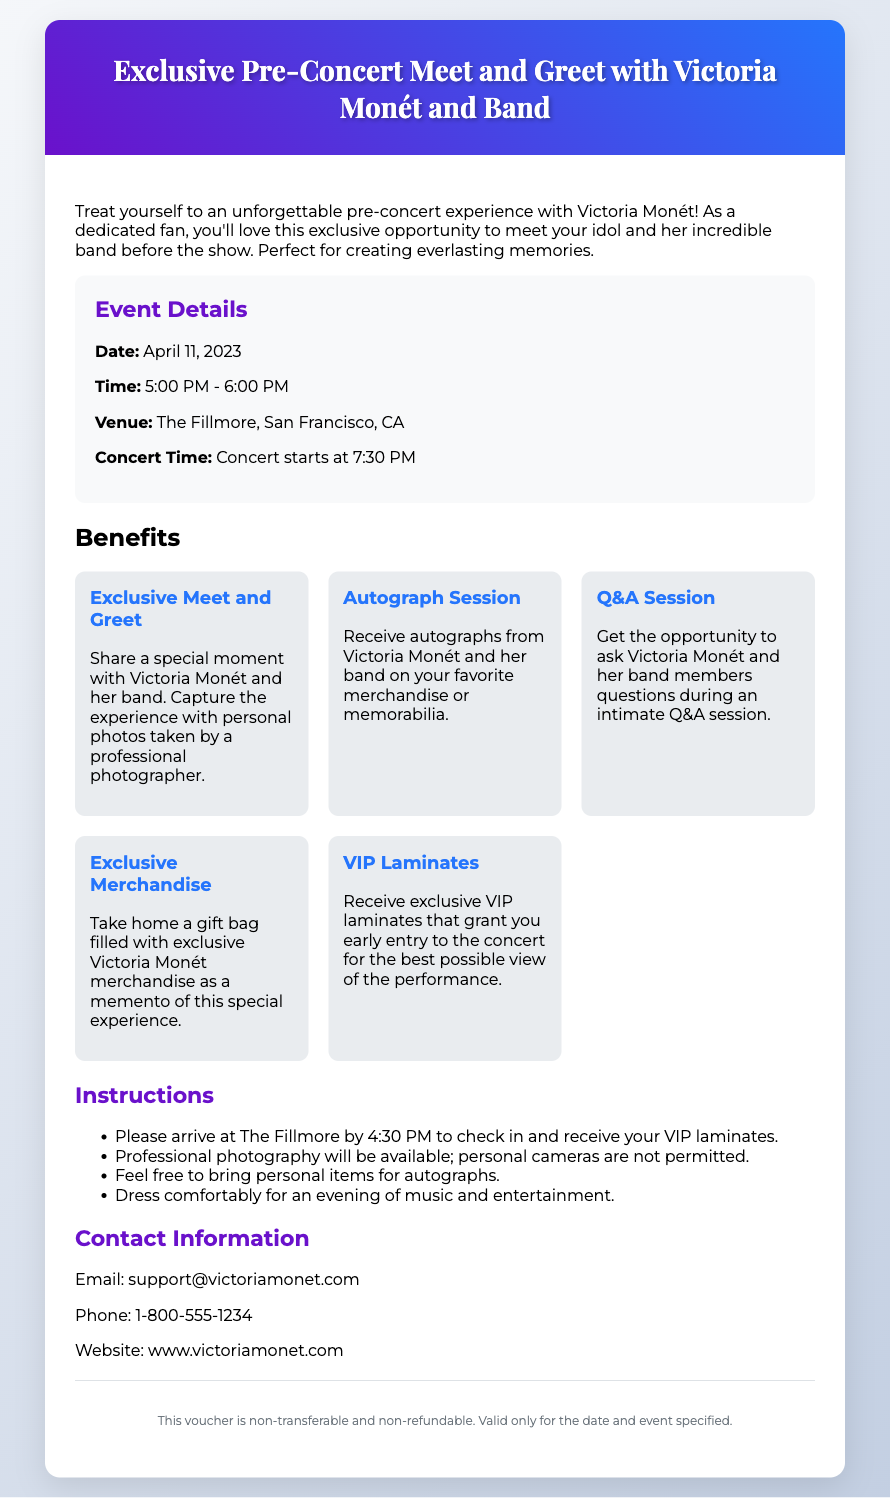What is the date of the event? The event date is specifically stated in the document.
Answer: April 11, 2023 What time does the meet and greet start? The document mentions the start time for the meet and greet experience.
Answer: 5:00 PM Where is the venue located? The venue name and location are provided in the document.
Answer: The Fillmore, San Francisco, CA What is one benefit of the meet and greet experience? The document lists several benefits; mentioning one is sufficient.
Answer: Exclusive Meet and Greet How long is the meet and greet session? This information can be inferred from the given time details in the document.
Answer: 1 hour What is the concert start time? The concert start time is explicitly stated in the document.
Answer: 7:30 PM What is required to check in for the event? The check-in instructions are detailed in the document.
Answer: Arrival by 4:30 PM What is included in the gift bag? The document specifically mentions exclusive items in the gift bag.
Answer: Exclusive Victoria Monét merchandise Is the voucher transferable? The document clearly states the terms related to the voucher.
Answer: Non-transferable 